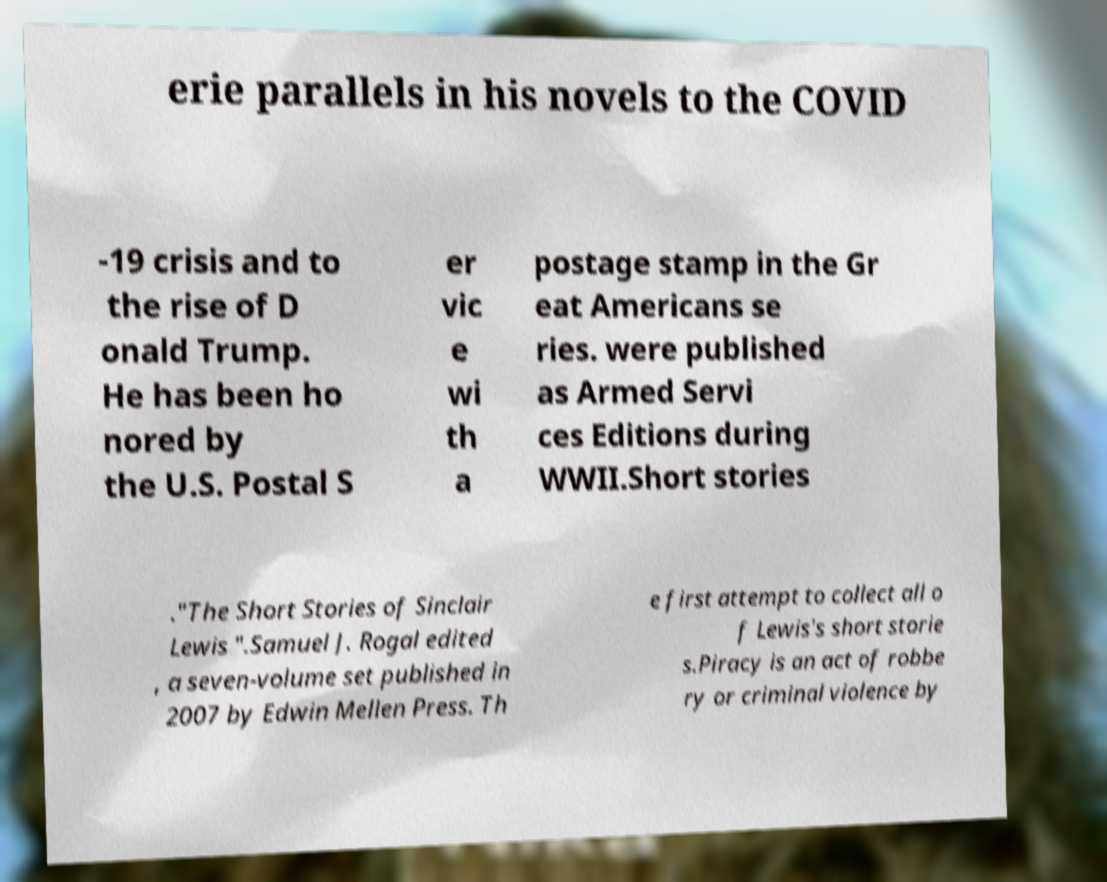What messages or text are displayed in this image? I need them in a readable, typed format. erie parallels in his novels to the COVID -19 crisis and to the rise of D onald Trump. He has been ho nored by the U.S. Postal S er vic e wi th a postage stamp in the Gr eat Americans se ries. were published as Armed Servi ces Editions during WWII.Short stories ."The Short Stories of Sinclair Lewis ".Samuel J. Rogal edited , a seven-volume set published in 2007 by Edwin Mellen Press. Th e first attempt to collect all o f Lewis's short storie s.Piracy is an act of robbe ry or criminal violence by 